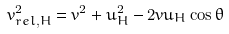Convert formula to latex. <formula><loc_0><loc_0><loc_500><loc_500>v _ { r e l , H } ^ { 2 } = v ^ { 2 } + u _ { H } ^ { 2 } - 2 v u _ { H } \cos \theta</formula> 